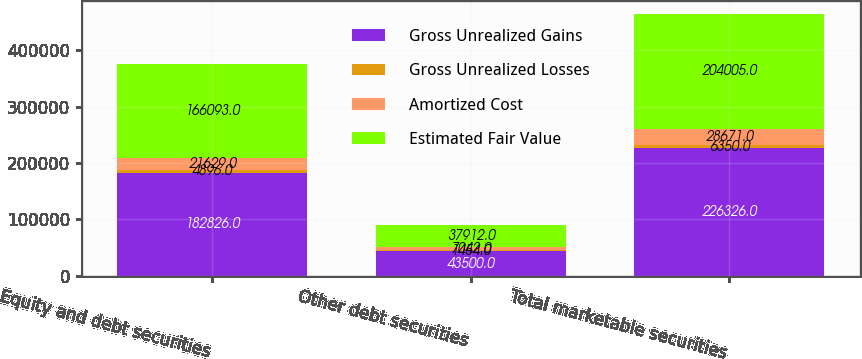Convert chart to OTSL. <chart><loc_0><loc_0><loc_500><loc_500><stacked_bar_chart><ecel><fcel>Equity and debt securities<fcel>Other debt securities<fcel>Total marketable securities<nl><fcel>Gross Unrealized Gains<fcel>182826<fcel>43500<fcel>226326<nl><fcel>Gross Unrealized Losses<fcel>4896<fcel>1454<fcel>6350<nl><fcel>Amortized Cost<fcel>21629<fcel>7042<fcel>28671<nl><fcel>Estimated Fair Value<fcel>166093<fcel>37912<fcel>204005<nl></chart> 